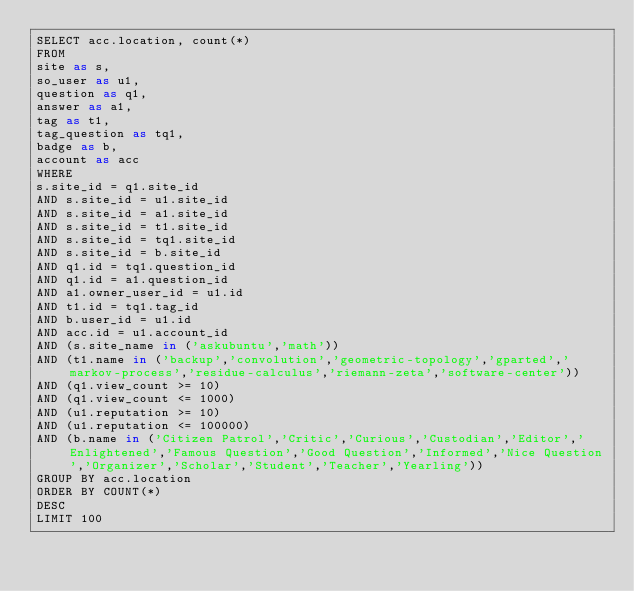Convert code to text. <code><loc_0><loc_0><loc_500><loc_500><_SQL_>SELECT acc.location, count(*)
FROM
site as s,
so_user as u1,
question as q1,
answer as a1,
tag as t1,
tag_question as tq1,
badge as b,
account as acc
WHERE
s.site_id = q1.site_id
AND s.site_id = u1.site_id
AND s.site_id = a1.site_id
AND s.site_id = t1.site_id
AND s.site_id = tq1.site_id
AND s.site_id = b.site_id
AND q1.id = tq1.question_id
AND q1.id = a1.question_id
AND a1.owner_user_id = u1.id
AND t1.id = tq1.tag_id
AND b.user_id = u1.id
AND acc.id = u1.account_id
AND (s.site_name in ('askubuntu','math'))
AND (t1.name in ('backup','convolution','geometric-topology','gparted','markov-process','residue-calculus','riemann-zeta','software-center'))
AND (q1.view_count >= 10)
AND (q1.view_count <= 1000)
AND (u1.reputation >= 10)
AND (u1.reputation <= 100000)
AND (b.name in ('Citizen Patrol','Critic','Curious','Custodian','Editor','Enlightened','Famous Question','Good Question','Informed','Nice Question','Organizer','Scholar','Student','Teacher','Yearling'))
GROUP BY acc.location
ORDER BY COUNT(*)
DESC
LIMIT 100
</code> 